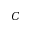Convert formula to latex. <formula><loc_0><loc_0><loc_500><loc_500>C</formula> 